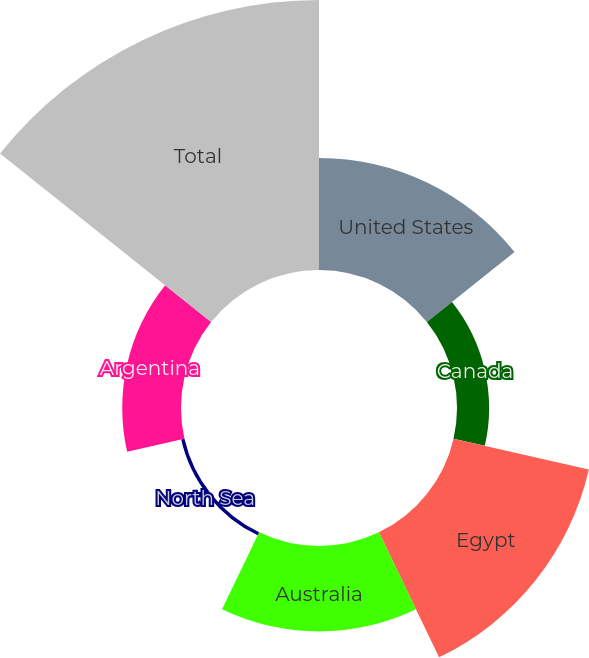Convert chart. <chart><loc_0><loc_0><loc_500><loc_500><pie_chart><fcel>United States<fcel>Canada<fcel>Egypt<fcel>Australia<fcel>North Sea<fcel>Argentina<fcel>Total<nl><fcel>16.0%<fcel>4.58%<fcel>19.81%<fcel>12.2%<fcel>0.48%<fcel>8.39%<fcel>38.54%<nl></chart> 